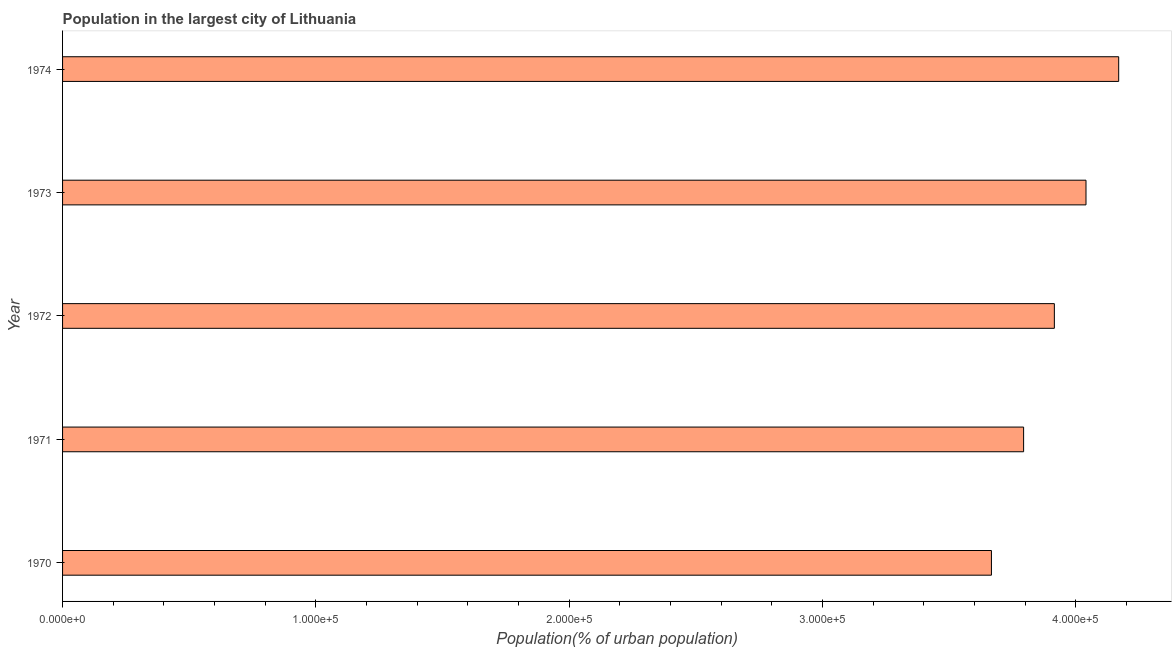Does the graph contain any zero values?
Your answer should be compact. No. What is the title of the graph?
Provide a succinct answer. Population in the largest city of Lithuania. What is the label or title of the X-axis?
Keep it short and to the point. Population(% of urban population). What is the label or title of the Y-axis?
Make the answer very short. Year. What is the population in largest city in 1971?
Your answer should be very brief. 3.79e+05. Across all years, what is the maximum population in largest city?
Make the answer very short. 4.17e+05. Across all years, what is the minimum population in largest city?
Your response must be concise. 3.67e+05. In which year was the population in largest city maximum?
Your response must be concise. 1974. In which year was the population in largest city minimum?
Offer a terse response. 1970. What is the sum of the population in largest city?
Your response must be concise. 1.96e+06. What is the difference between the population in largest city in 1971 and 1973?
Your answer should be very brief. -2.46e+04. What is the average population in largest city per year?
Your answer should be very brief. 3.92e+05. What is the median population in largest city?
Offer a very short reply. 3.92e+05. In how many years, is the population in largest city greater than 340000 %?
Offer a terse response. 5. Do a majority of the years between 1974 and 1971 (inclusive) have population in largest city greater than 140000 %?
Provide a succinct answer. Yes. What is the ratio of the population in largest city in 1972 to that in 1974?
Offer a very short reply. 0.94. Is the population in largest city in 1970 less than that in 1974?
Your response must be concise. Yes. What is the difference between the highest and the second highest population in largest city?
Provide a succinct answer. 1.29e+04. Is the sum of the population in largest city in 1970 and 1971 greater than the maximum population in largest city across all years?
Offer a very short reply. Yes. What is the difference between the highest and the lowest population in largest city?
Provide a succinct answer. 5.02e+04. How many bars are there?
Offer a very short reply. 5. Are all the bars in the graph horizontal?
Your response must be concise. Yes. How many years are there in the graph?
Offer a very short reply. 5. Are the values on the major ticks of X-axis written in scientific E-notation?
Your answer should be very brief. Yes. What is the Population(% of urban population) in 1970?
Keep it short and to the point. 3.67e+05. What is the Population(% of urban population) in 1971?
Keep it short and to the point. 3.79e+05. What is the Population(% of urban population) in 1972?
Ensure brevity in your answer.  3.92e+05. What is the Population(% of urban population) of 1973?
Offer a terse response. 4.04e+05. What is the Population(% of urban population) in 1974?
Your answer should be very brief. 4.17e+05. What is the difference between the Population(% of urban population) in 1970 and 1971?
Keep it short and to the point. -1.27e+04. What is the difference between the Population(% of urban population) in 1970 and 1972?
Offer a terse response. -2.48e+04. What is the difference between the Population(% of urban population) in 1970 and 1973?
Your answer should be compact. -3.73e+04. What is the difference between the Population(% of urban population) in 1970 and 1974?
Your response must be concise. -5.02e+04. What is the difference between the Population(% of urban population) in 1971 and 1972?
Your response must be concise. -1.21e+04. What is the difference between the Population(% of urban population) in 1971 and 1973?
Keep it short and to the point. -2.46e+04. What is the difference between the Population(% of urban population) in 1971 and 1974?
Provide a short and direct response. -3.75e+04. What is the difference between the Population(% of urban population) in 1972 and 1973?
Provide a succinct answer. -1.25e+04. What is the difference between the Population(% of urban population) in 1972 and 1974?
Keep it short and to the point. -2.54e+04. What is the difference between the Population(% of urban population) in 1973 and 1974?
Ensure brevity in your answer.  -1.29e+04. What is the ratio of the Population(% of urban population) in 1970 to that in 1972?
Make the answer very short. 0.94. What is the ratio of the Population(% of urban population) in 1970 to that in 1973?
Keep it short and to the point. 0.91. What is the ratio of the Population(% of urban population) in 1970 to that in 1974?
Give a very brief answer. 0.88. What is the ratio of the Population(% of urban population) in 1971 to that in 1972?
Ensure brevity in your answer.  0.97. What is the ratio of the Population(% of urban population) in 1971 to that in 1973?
Offer a terse response. 0.94. What is the ratio of the Population(% of urban population) in 1971 to that in 1974?
Offer a very short reply. 0.91. What is the ratio of the Population(% of urban population) in 1972 to that in 1974?
Make the answer very short. 0.94. 